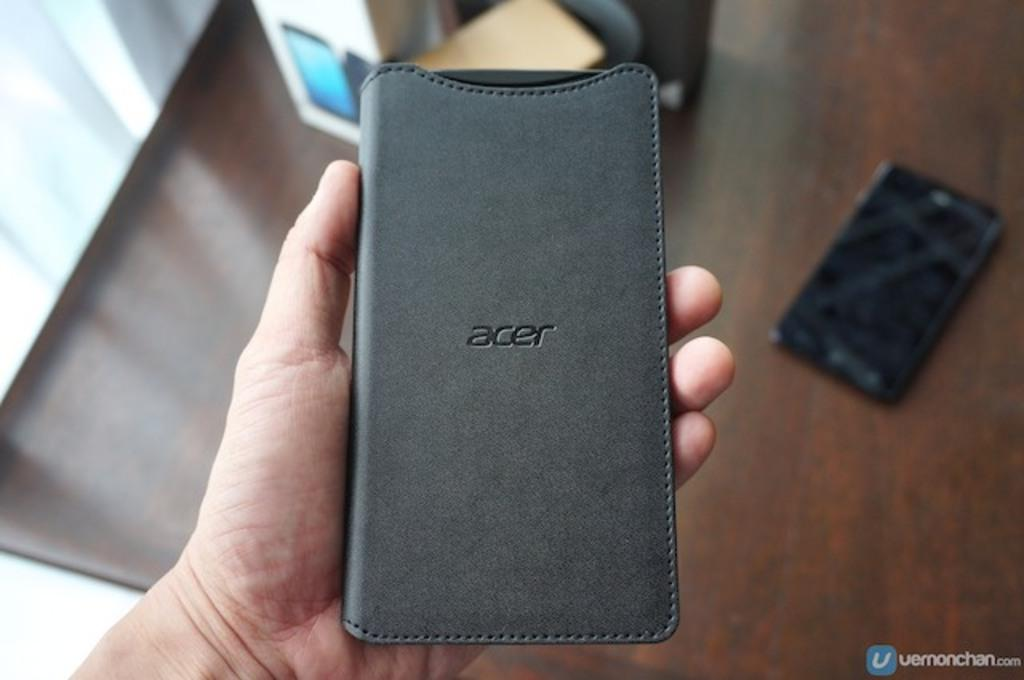<image>
Relay a brief, clear account of the picture shown. A phone protector with the brand acer emblazoned on the center of it. 